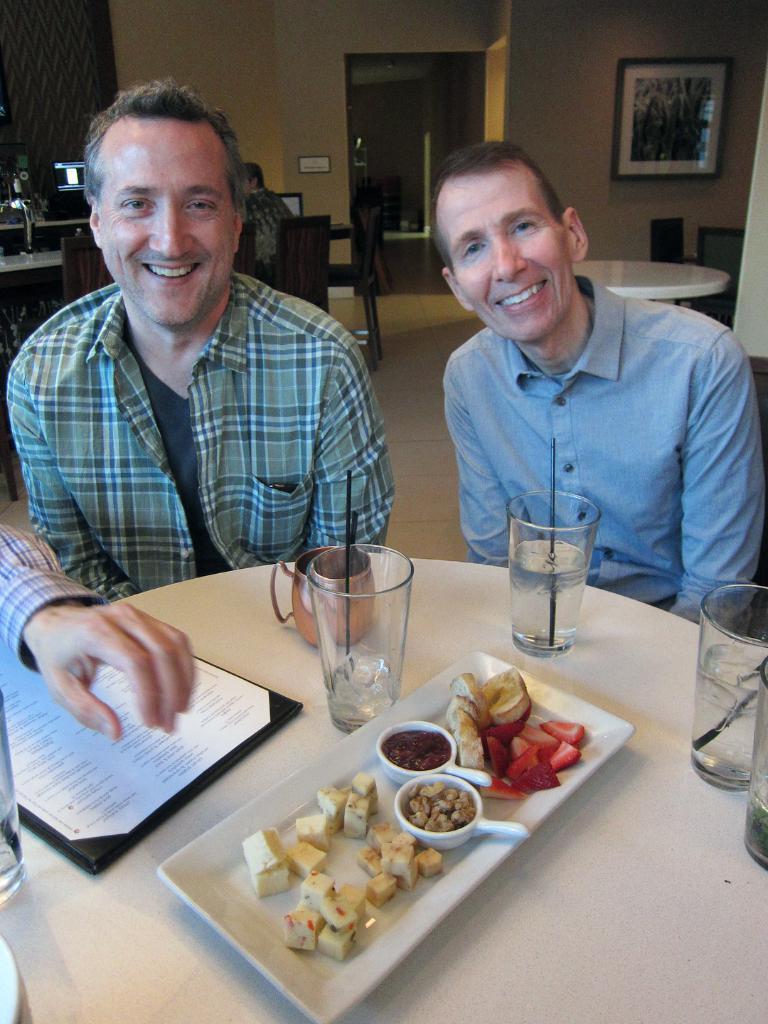How would you summarize this image in a sentence or two? In this picture we can see two persons sitting on the chairs. This is the table. On the table there is plate, glasses, and a cup. And there is a paper on the table. And this is the food. On the background we can see the wall and there is a frame on the wall. Even we can see a one more person sitting on the chair. 